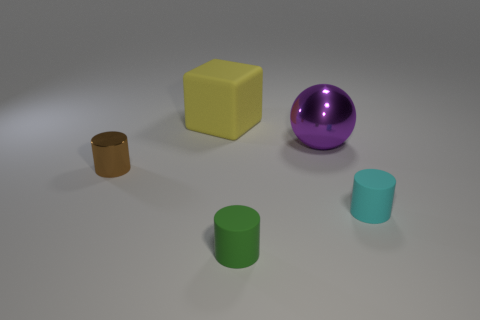Add 4 red matte cylinders. How many objects exist? 9 Subtract all cylinders. How many objects are left? 2 Subtract all small green matte things. Subtract all large purple balls. How many objects are left? 3 Add 1 metal balls. How many metal balls are left? 2 Add 4 small blocks. How many small blocks exist? 4 Subtract 0 blue cubes. How many objects are left? 5 